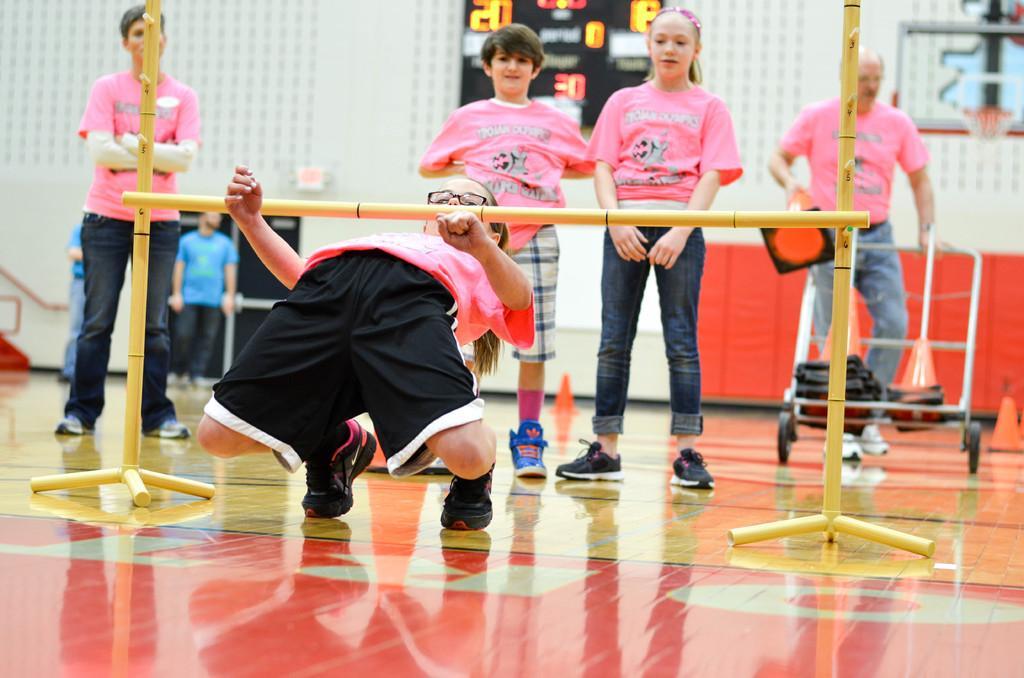Could you give a brief overview of what you see in this image? In this image we can see this person wearing pink T-shirt, shoes and spectacles is crossing the pole. Here we can see these people wearing pink T-shirts are standing on the ground, here we can see the trolley. In the background, we can see two persons in blue T-shirts and standing near the wall, we can see LED board and we can see the net here. 